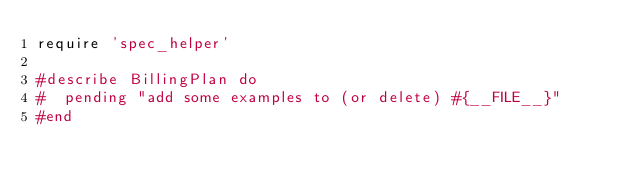<code> <loc_0><loc_0><loc_500><loc_500><_Ruby_>require 'spec_helper'

#describe BillingPlan do
#  pending "add some examples to (or delete) #{__FILE__}"
#end
</code> 